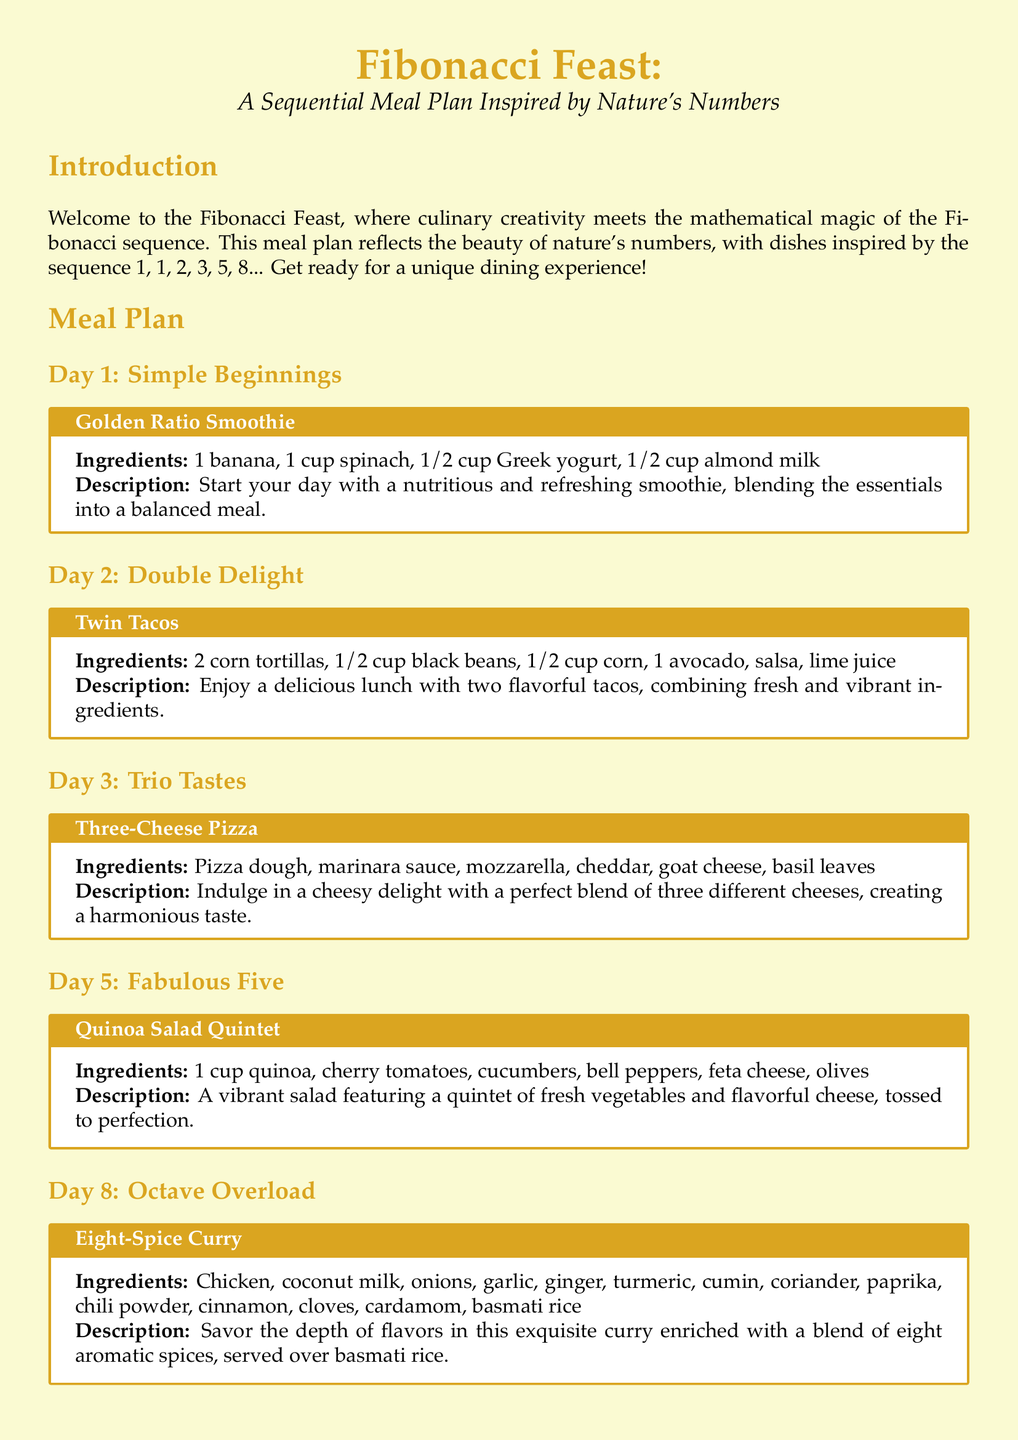what is the title of the meal plan? The title of the meal plan is stated at the beginning of the document as "Fibonacci Feast: A Sequential Meal Plan Inspired by Nature’s Numbers."
Answer: Fibonacci Feast how many ingredients are in the Golden Ratio Smoothie? The number of ingredients in the Golden Ratio Smoothie is gathered from the list provided, which includes four items.
Answer: 4 what dish is served on Day 3? The dish served on Day 3 is mentioned in the meal plan as "Three-Cheese Pizza."
Answer: Three-Cheese Pizza how many tacos are included in the Twin Tacos meal? The Twin Tacos meal includes tacos as noted in the title, implying there are two tacos.
Answer: 2 what is the main ingredient in the Eight-Spice Curry? The main ingredient of the Eight-Spice Curry is identified in the recipe, which is chicken.
Answer: Chicken how many different spices are used in the Eight-Spice Curry? The number of spices used in the Eight-Spice Curry is explained in the ingredients list, which mentions eight spices explicitly.
Answer: 8 what type of salad is featured on Day 5? The type of salad featured on Day 5 is referred to as "Quinoa Salad Quintet."
Answer: Quinoa Salad Quintet what is the common theme of the meal plan? The common theme of the meal plan is referenced in the introduction, which highlights the inspiration from the Fibonacci sequence.
Answer: Fibonacci sequence 